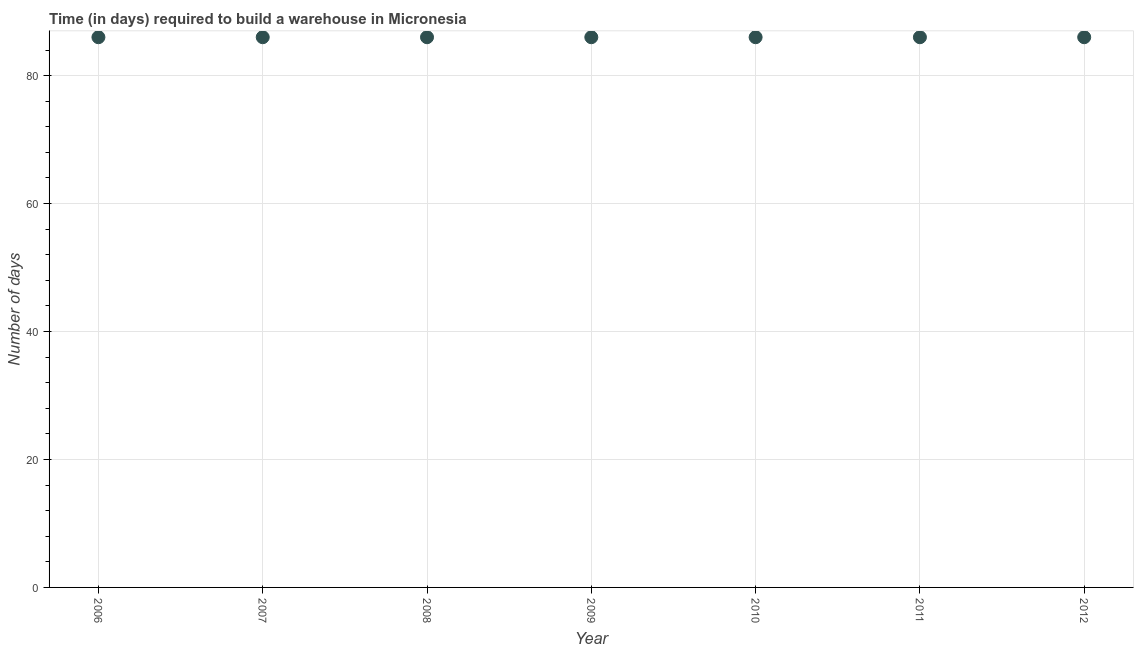What is the time required to build a warehouse in 2010?
Your answer should be compact. 86. Across all years, what is the maximum time required to build a warehouse?
Offer a very short reply. 86. Across all years, what is the minimum time required to build a warehouse?
Your answer should be very brief. 86. What is the sum of the time required to build a warehouse?
Give a very brief answer. 602. What is the difference between the time required to build a warehouse in 2006 and 2008?
Offer a terse response. 0. What is the median time required to build a warehouse?
Your answer should be very brief. 86. In how many years, is the time required to build a warehouse greater than 24 days?
Make the answer very short. 7. Do a majority of the years between 2007 and 2010 (inclusive) have time required to build a warehouse greater than 40 days?
Your answer should be very brief. Yes. What is the ratio of the time required to build a warehouse in 2009 to that in 2012?
Your response must be concise. 1. Is the time required to build a warehouse in 2007 less than that in 2010?
Ensure brevity in your answer.  No. Is the difference between the time required to build a warehouse in 2007 and 2012 greater than the difference between any two years?
Your answer should be compact. Yes. Is the sum of the time required to build a warehouse in 2008 and 2011 greater than the maximum time required to build a warehouse across all years?
Offer a very short reply. Yes. Does the time required to build a warehouse monotonically increase over the years?
Make the answer very short. No. How many dotlines are there?
Offer a very short reply. 1. What is the difference between two consecutive major ticks on the Y-axis?
Provide a short and direct response. 20. Does the graph contain any zero values?
Provide a short and direct response. No. Does the graph contain grids?
Keep it short and to the point. Yes. What is the title of the graph?
Provide a succinct answer. Time (in days) required to build a warehouse in Micronesia. What is the label or title of the X-axis?
Your response must be concise. Year. What is the label or title of the Y-axis?
Provide a short and direct response. Number of days. What is the Number of days in 2007?
Offer a terse response. 86. What is the Number of days in 2009?
Give a very brief answer. 86. What is the Number of days in 2010?
Offer a terse response. 86. What is the Number of days in 2011?
Your answer should be very brief. 86. What is the difference between the Number of days in 2006 and 2007?
Offer a terse response. 0. What is the difference between the Number of days in 2006 and 2008?
Offer a terse response. 0. What is the difference between the Number of days in 2007 and 2010?
Your answer should be compact. 0. What is the difference between the Number of days in 2007 and 2012?
Give a very brief answer. 0. What is the difference between the Number of days in 2008 and 2009?
Your answer should be very brief. 0. What is the difference between the Number of days in 2008 and 2010?
Provide a succinct answer. 0. What is the difference between the Number of days in 2008 and 2011?
Provide a short and direct response. 0. What is the difference between the Number of days in 2009 and 2012?
Keep it short and to the point. 0. What is the difference between the Number of days in 2010 and 2011?
Offer a terse response. 0. What is the ratio of the Number of days in 2006 to that in 2007?
Provide a succinct answer. 1. What is the ratio of the Number of days in 2006 to that in 2010?
Offer a terse response. 1. What is the ratio of the Number of days in 2006 to that in 2011?
Your response must be concise. 1. What is the ratio of the Number of days in 2006 to that in 2012?
Offer a very short reply. 1. What is the ratio of the Number of days in 2007 to that in 2009?
Give a very brief answer. 1. What is the ratio of the Number of days in 2007 to that in 2011?
Keep it short and to the point. 1. What is the ratio of the Number of days in 2008 to that in 2010?
Offer a very short reply. 1. What is the ratio of the Number of days in 2009 to that in 2010?
Provide a succinct answer. 1. What is the ratio of the Number of days in 2010 to that in 2011?
Make the answer very short. 1. What is the ratio of the Number of days in 2011 to that in 2012?
Offer a terse response. 1. 